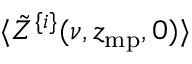Convert formula to latex. <formula><loc_0><loc_0><loc_500><loc_500>\langle \tilde { Z } ^ { \{ i \} } ( \nu , z _ { m p } , 0 ) \rangle</formula> 